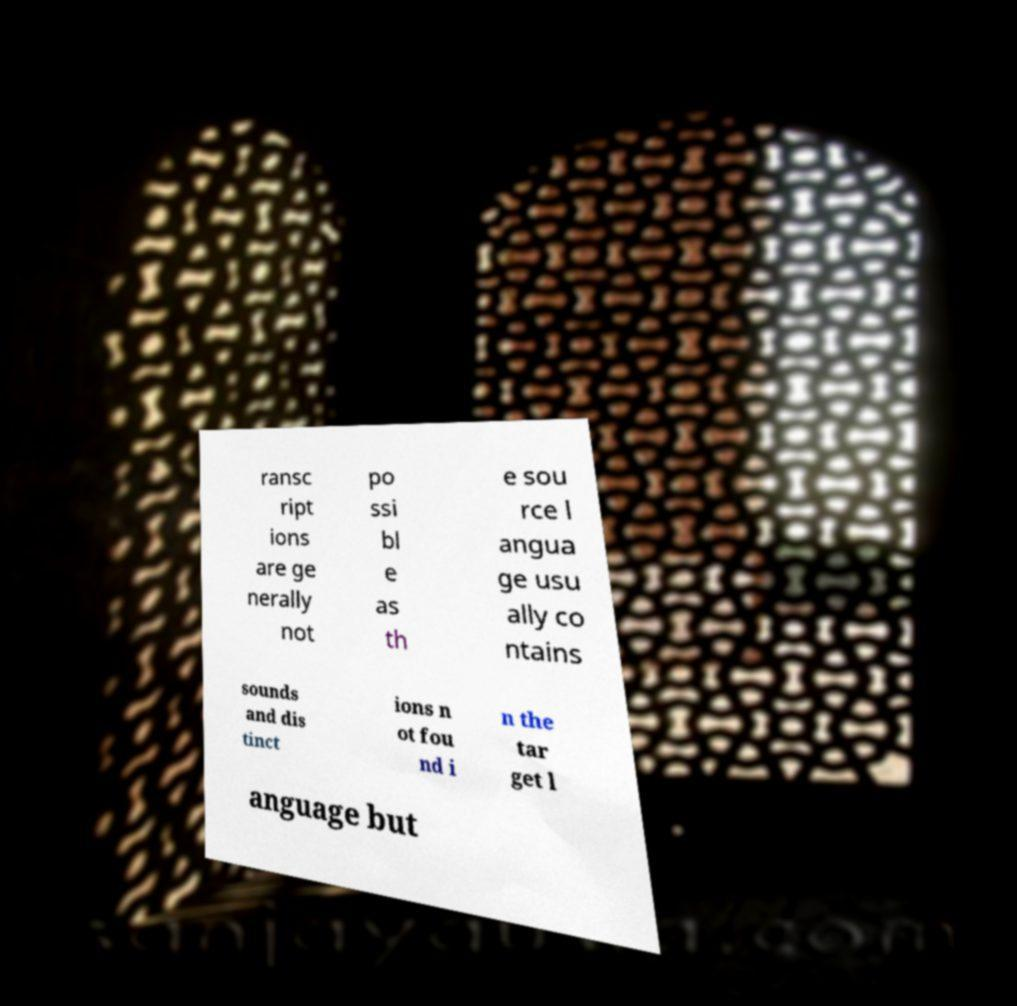Please identify and transcribe the text found in this image. ransc ript ions are ge nerally not po ssi bl e as th e sou rce l angua ge usu ally co ntains sounds and dis tinct ions n ot fou nd i n the tar get l anguage but 